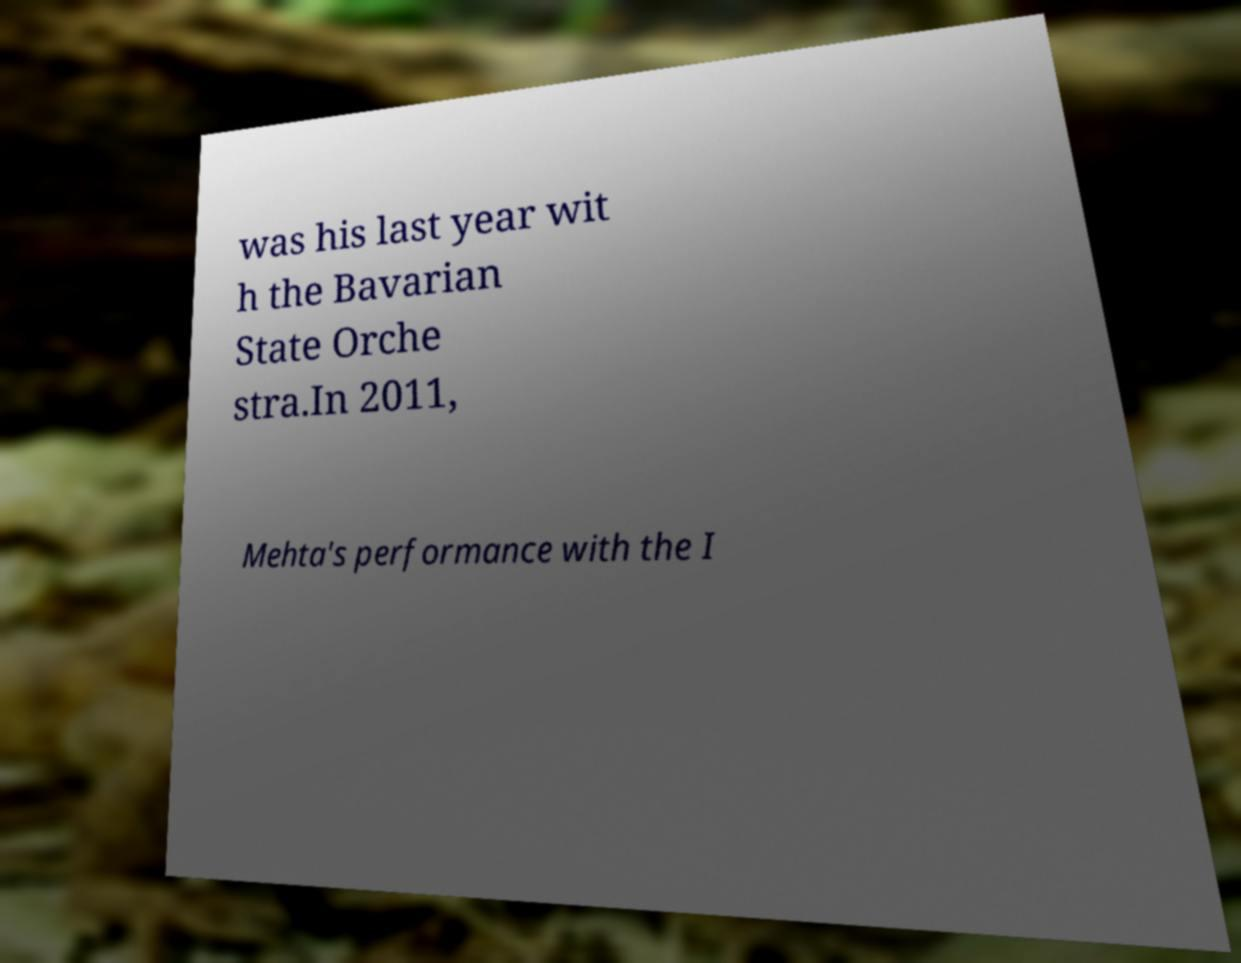Could you extract and type out the text from this image? was his last year wit h the Bavarian State Orche stra.In 2011, Mehta's performance with the I 